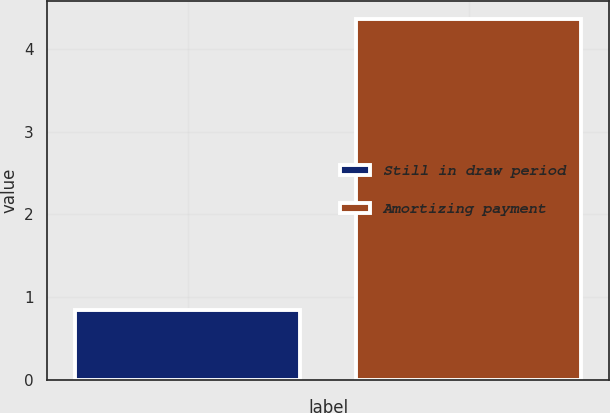Convert chart to OTSL. <chart><loc_0><loc_0><loc_500><loc_500><bar_chart><fcel>Still in draw period<fcel>Amortizing payment<nl><fcel>0.84<fcel>4.36<nl></chart> 